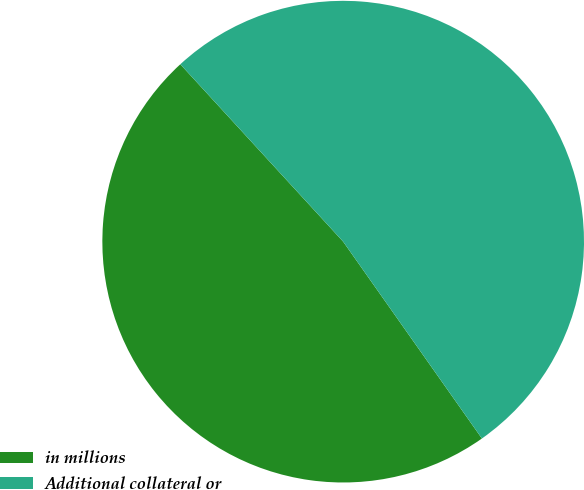<chart> <loc_0><loc_0><loc_500><loc_500><pie_chart><fcel>in millions<fcel>Additional collateral or<nl><fcel>47.95%<fcel>52.05%<nl></chart> 